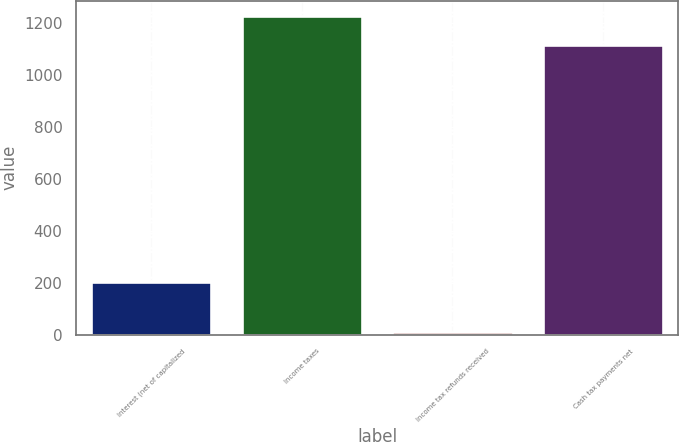<chart> <loc_0><loc_0><loc_500><loc_500><bar_chart><fcel>Interest (net of capitalized<fcel>Income taxes<fcel>Income tax refunds received<fcel>Cash tax payments net<nl><fcel>201<fcel>1224.3<fcel>9<fcel>1113<nl></chart> 